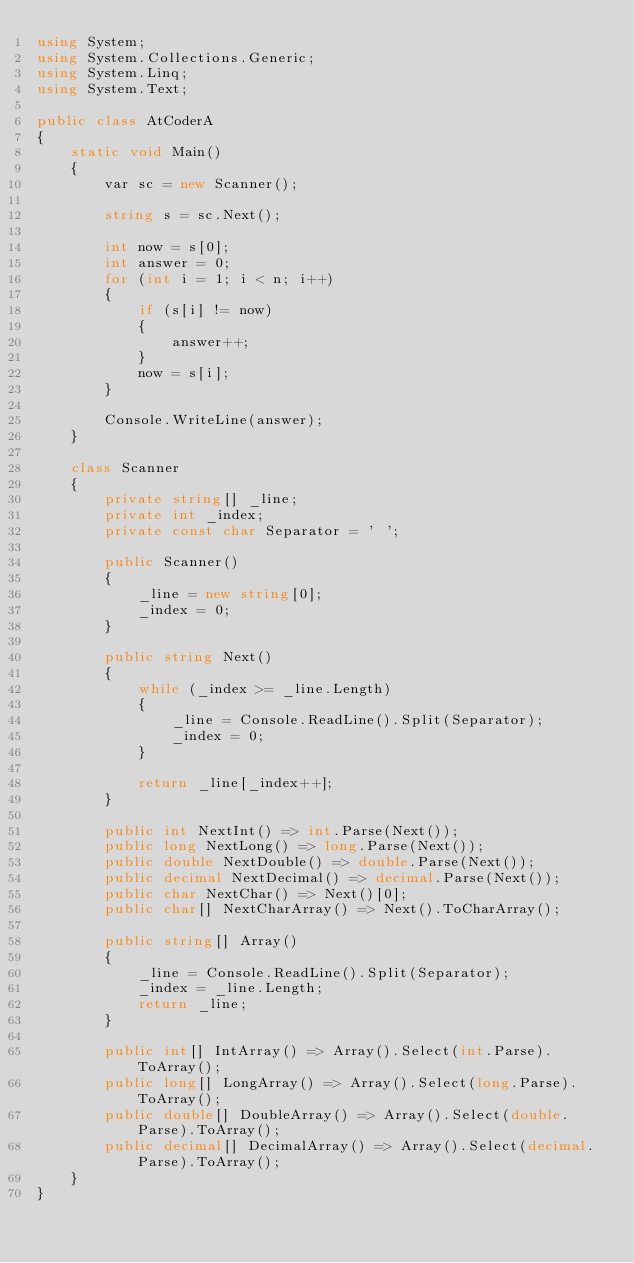Convert code to text. <code><loc_0><loc_0><loc_500><loc_500><_C#_>using System;
using System.Collections.Generic;
using System.Linq;
using System.Text;

public class AtCoderA
{
    static void Main()
    {
        var sc = new Scanner();

        string s = sc.Next();

        int now = s[0];
        int answer = 0;
        for (int i = 1; i < n; i++)
        {
            if (s[i] != now)
            {
                answer++;
            }
            now = s[i];
        }

        Console.WriteLine(answer);
    }

    class Scanner
    {
        private string[] _line;
        private int _index;
        private const char Separator = ' ';

        public Scanner()
        {
            _line = new string[0];
            _index = 0;
        }

        public string Next()
        {
            while (_index >= _line.Length)
            {
                _line = Console.ReadLine().Split(Separator);
                _index = 0;
            }

            return _line[_index++];
        }

        public int NextInt() => int.Parse(Next());
        public long NextLong() => long.Parse(Next());
        public double NextDouble() => double.Parse(Next());
        public decimal NextDecimal() => decimal.Parse(Next());
        public char NextChar() => Next()[0];
        public char[] NextCharArray() => Next().ToCharArray();

        public string[] Array()
        {
            _line = Console.ReadLine().Split(Separator);
            _index = _line.Length;
            return _line;
        }

        public int[] IntArray() => Array().Select(int.Parse).ToArray();
        public long[] LongArray() => Array().Select(long.Parse).ToArray();
        public double[] DoubleArray() => Array().Select(double.Parse).ToArray();
        public decimal[] DecimalArray() => Array().Select(decimal.Parse).ToArray();
    }
}</code> 